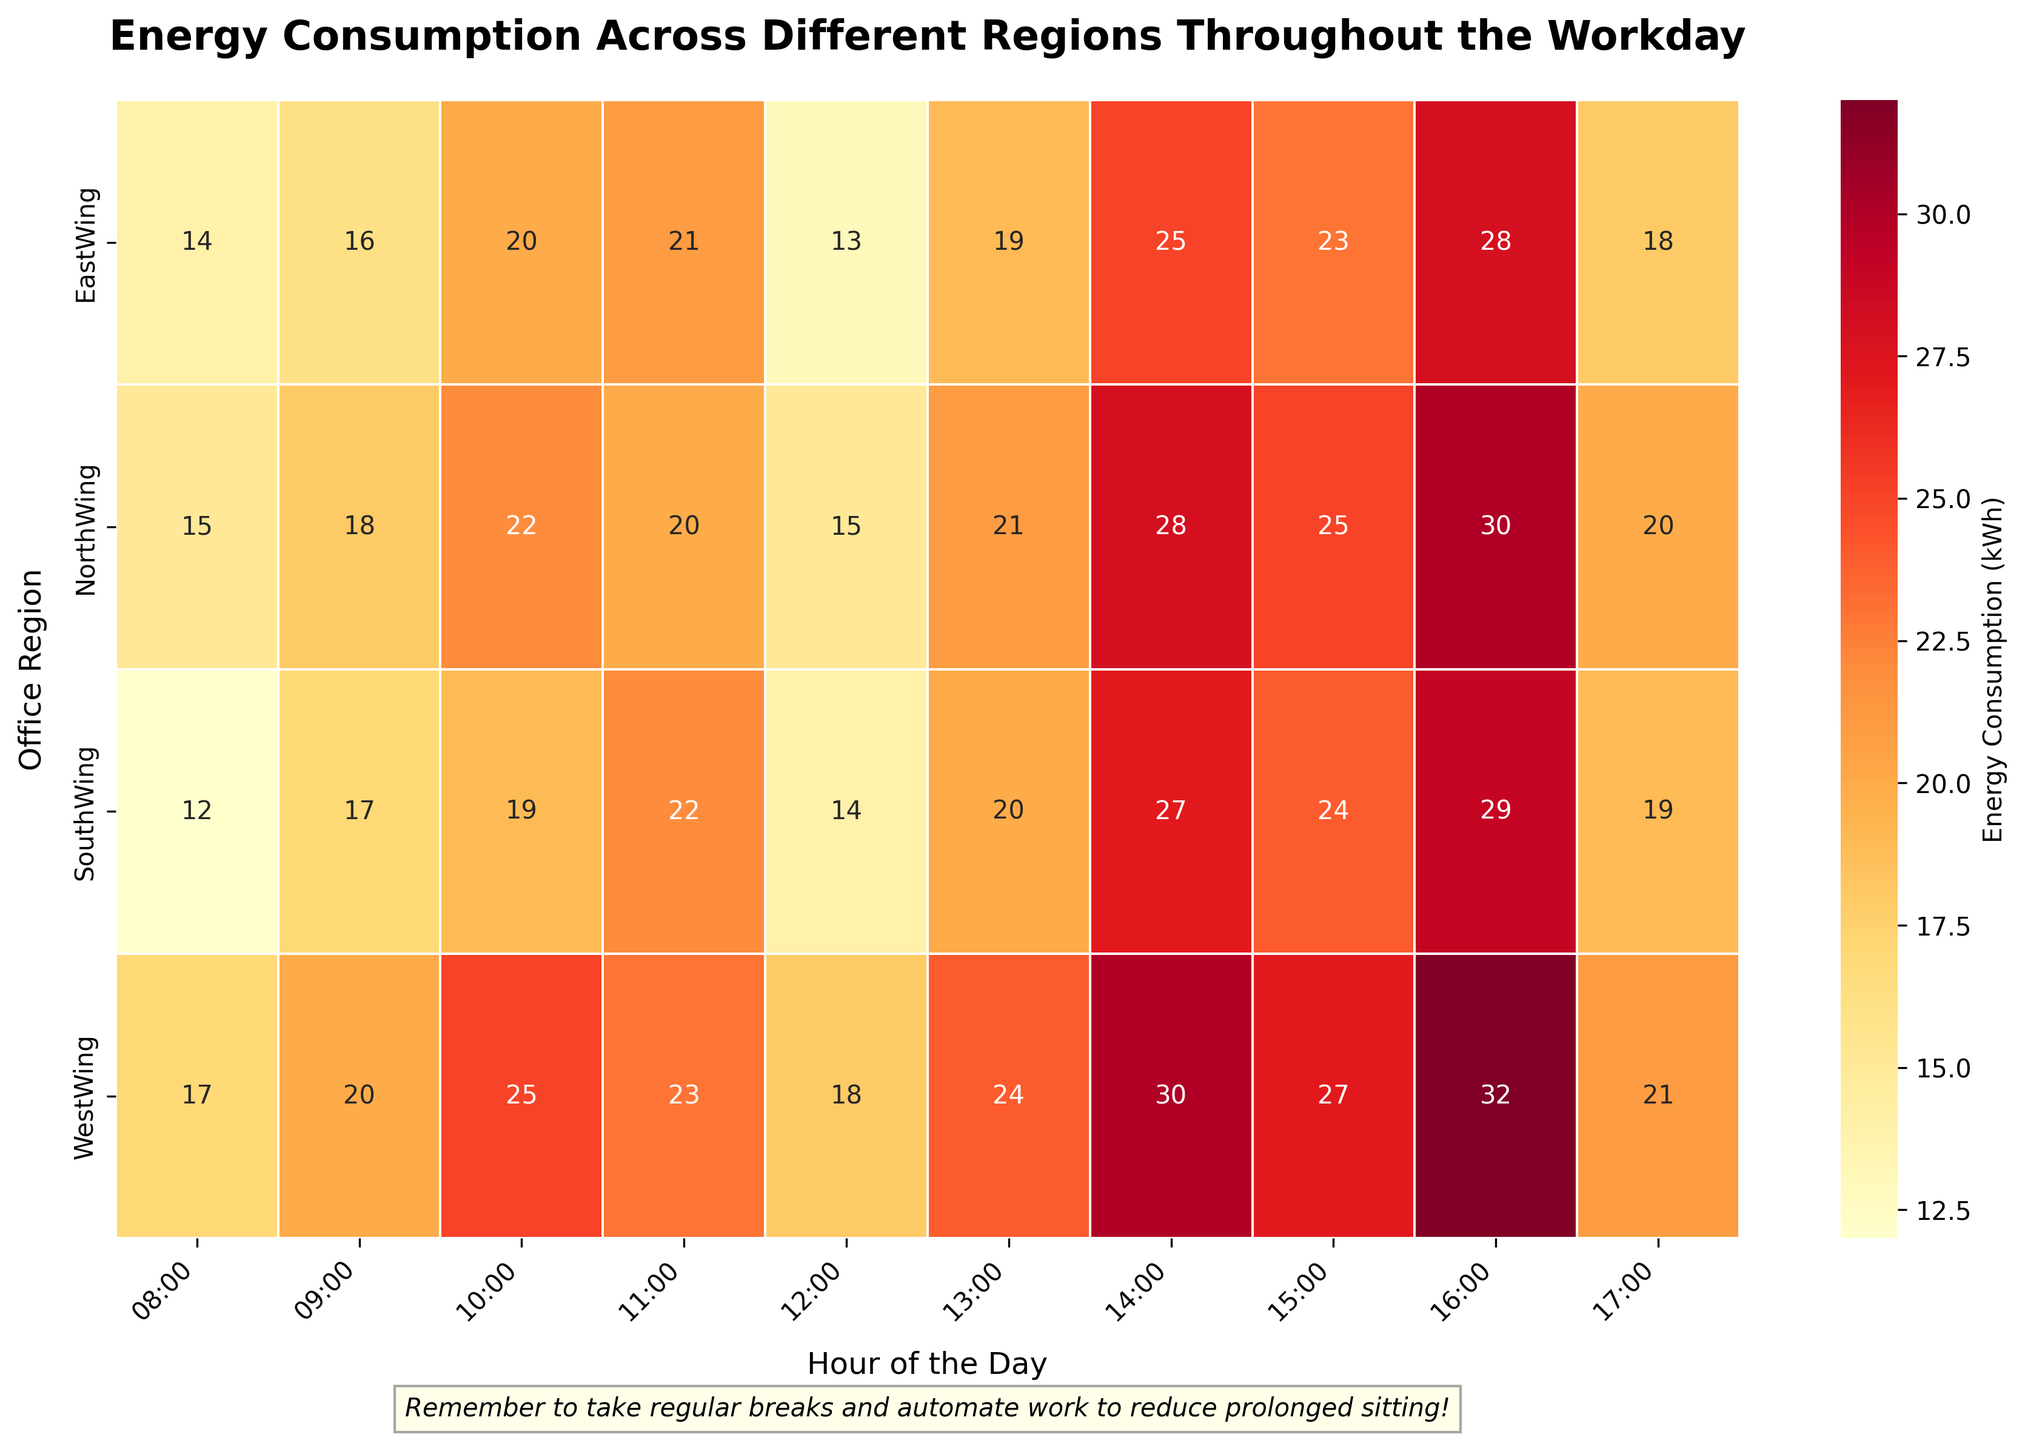What is the title of the heatmap? The title is typically displayed at the top center of the plot. Here, the title explicitly states the context and purpose of the plot, which is "Energy Consumption Across Different Regions Throughout the Workday".
Answer: Energy Consumption Across Different Regions Throughout the Workday What is the energy consumption value for the North Wing at 14:00? By locating the 'North Wing' row and the '14:00' column intersect, we can see the value displayed on the heatmap at that cell.
Answer: 28 kWh Which region shows the highest energy consumption at 16:00? By scanning the column under '16:00' for the highest value and noting its corresponding region on the y-axis, we find that 'West Wing' has the highest value.
Answer: West Wing At what time does the South Wing have the lowest energy consumption? By scanning the row labeled 'South Wing' and identifying the lowest value, we see that the time corresponding to this value is '08:00'.
Answer: 08:00 Which region shows a consistent increase in energy consumption throughout the day? By observing the trend from '08:00' to '17:00' in each region's row, we see that the 'West Wing' has a clear, consistent increase in values.
Answer: West Wing What's the average energy consumption in the East Wing for hours 10:00 to 12:00? The values for 'East Wing' at '10:00', '11:00', and '12:00' are 20, 21, and 13 respectively. Summing these values (20 + 21 + 13 = 54) and dividing by the number of points (54 / 3), we get the average.
Answer: 18 kWh Compare the energy consumption between East Wing and North Wing at 11:00. Which one is higher? By checking the values for both 'East Wing' and 'North Wing' at '11:00', we find that 'East Wing' is 21 and 'North Wing' is 20. Therefore, 'East Wing' is higher.
Answer: East Wing At which hour does the North Wing experience its peak energy consumption? By examining the row for 'North Wing' and identifying the highest value, which is 30 kWh, we see that it occurs at '16:00'.
Answer: 16:00 What is the total energy consumption for the West Wing across the entire workday? By summing all the energy consumption values in the 'West Wing' row (17 + 20 + 25 + 23 + 18 + 24 + 30 + 27 + 32 + 21), we get a total of 237 kWh.
Answer: 237 kWh 